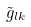<formula> <loc_0><loc_0><loc_500><loc_500>\tilde { g } _ { l k }</formula> 